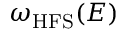Convert formula to latex. <formula><loc_0><loc_0><loc_500><loc_500>\omega _ { H F S } ( E )</formula> 